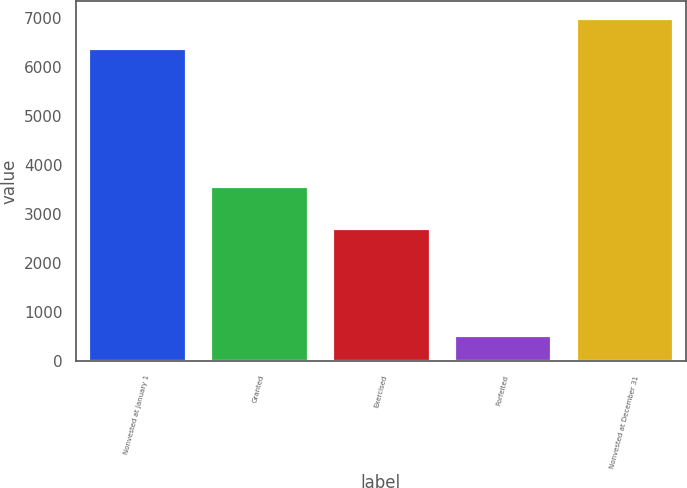<chart> <loc_0><loc_0><loc_500><loc_500><bar_chart><fcel>Nonvested at January 1<fcel>Granted<fcel>Exercised<fcel>Forfeited<fcel>Nonvested at December 31<nl><fcel>6379<fcel>3583<fcel>2720<fcel>532<fcel>6996.8<nl></chart> 